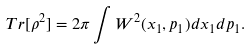<formula> <loc_0><loc_0><loc_500><loc_500>T r [ \rho ^ { 2 } ] = 2 \pi \int W ^ { 2 } ( x _ { 1 } , p _ { 1 } ) d x _ { 1 } d p _ { 1 } .</formula> 